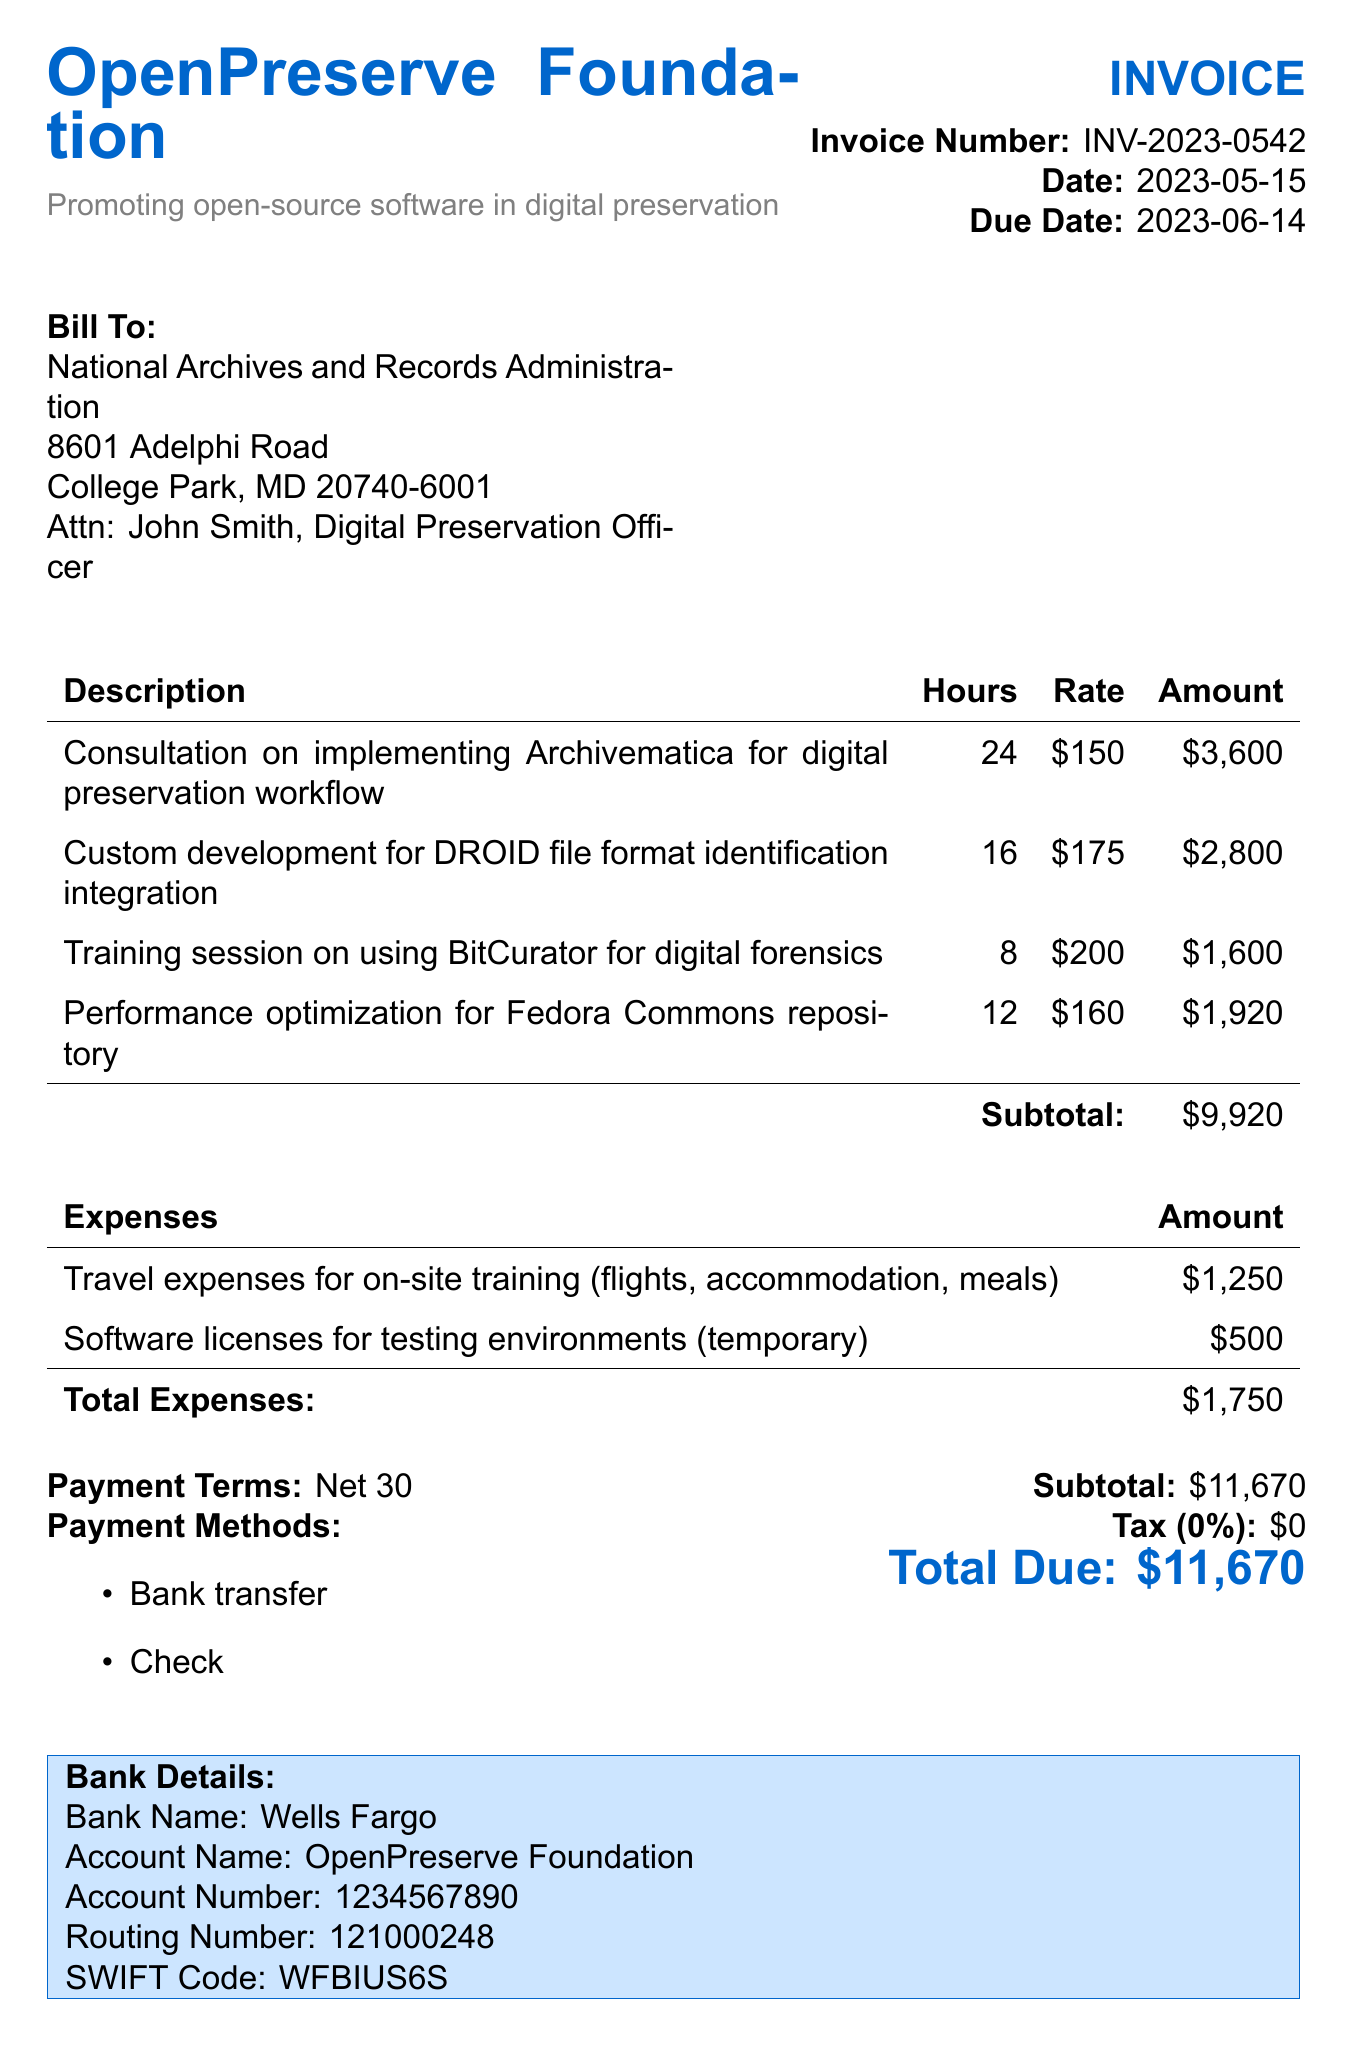what is the invoice number? The invoice number is listed at the top of the document.
Answer: INV-2023-0542 who is the bill to organization? The bill to organization is specified in the document.
Answer: National Archives and Records Administration what is the total amount due? The total amount due is calculated at the bottom of the invoice.
Answer: $11,670 how many hours were billed for the consultation on Archivematica? The hours for each service are detailed in the service section.
Answer: 24 what is the payment term specified in the invoice? The payment term is provided near the payment methods section.
Answer: Net 30 how much was charged for travel expenses? The expenses are listed, specifying the amount charged for travel.
Answer: $1,250 what is the due date for this invoice? The due date is mentioned near the top of the document.
Answer: 2023-06-14 what services required custom development? The services section details which services were rendered.
Answer: Custom development for DROID file format identification integration what is the tax rate applied to this invoice? The tax rate is indicated in the financial summary section of the document.
Answer: 0% 